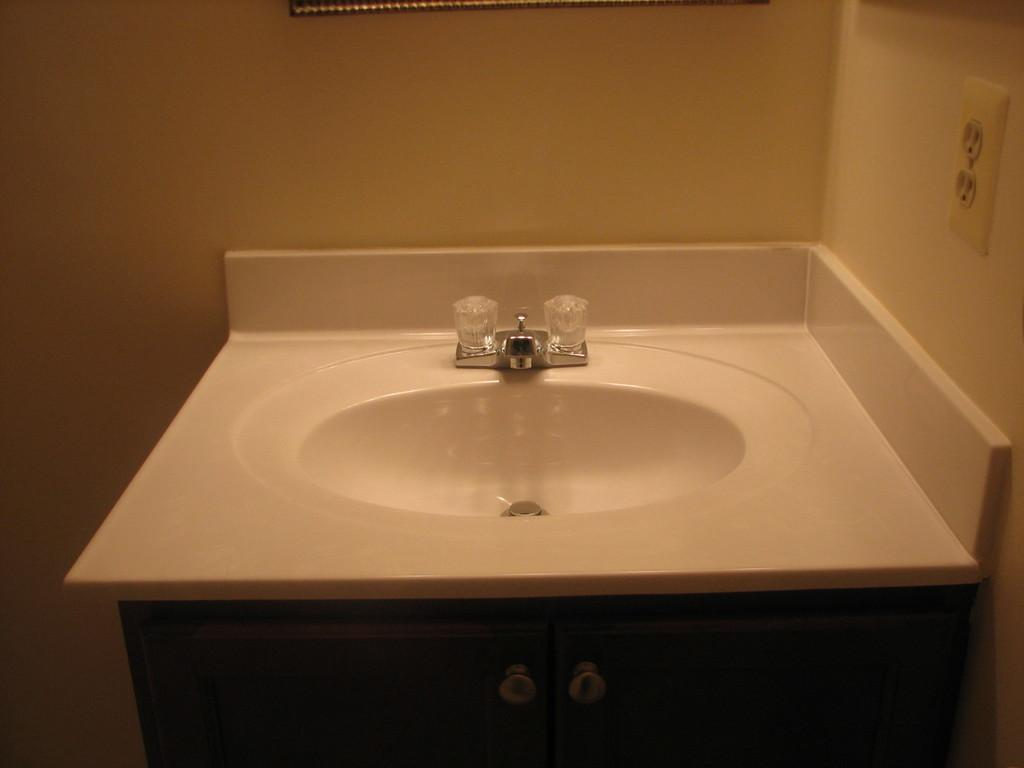What type of fixture is in the image? There is a sink in the image. What is attached to the sink in the image? There is a tap attached to the sink in the image. Where are the sink and tap located in the image? The sink and tap are in the center of the image. What type of sail can be seen on the sun in the image? There is no sail or sun present in the image; it only features a sink and tap. 